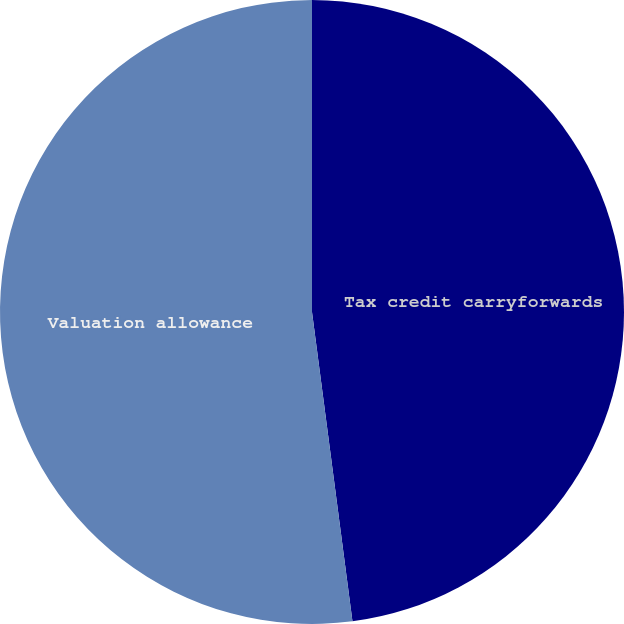Convert chart to OTSL. <chart><loc_0><loc_0><loc_500><loc_500><pie_chart><fcel>Tax credit carryforwards<fcel>Valuation allowance<nl><fcel>47.93%<fcel>52.07%<nl></chart> 